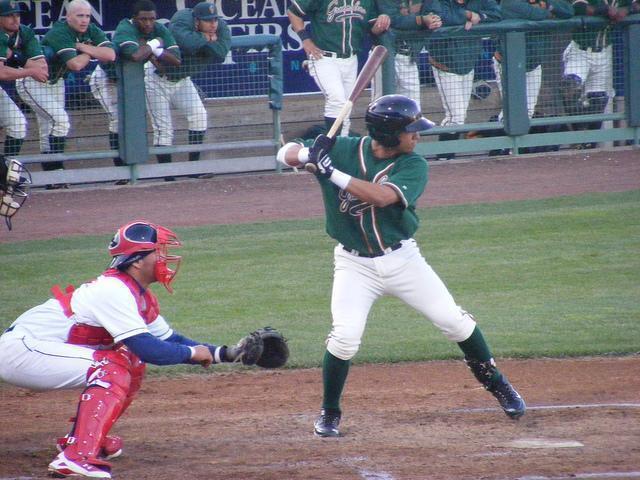What is going to approach the two men in front soon?
Indicate the correct choice and explain in the format: 'Answer: answer
Rationale: rationale.'
Options: Baseball, frisbee, bullet, football. Answer: baseball.
Rationale: The two men are at home plate and the pitch will come in soon and it will be a baseball. 